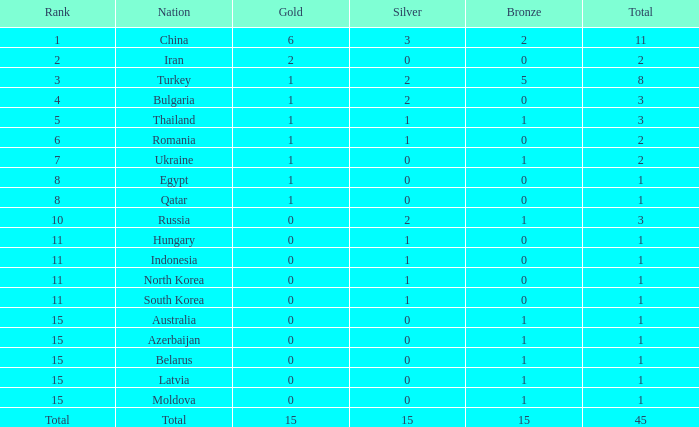What is the sum of the bronze medals of the nation with less than 0 silvers? None. 